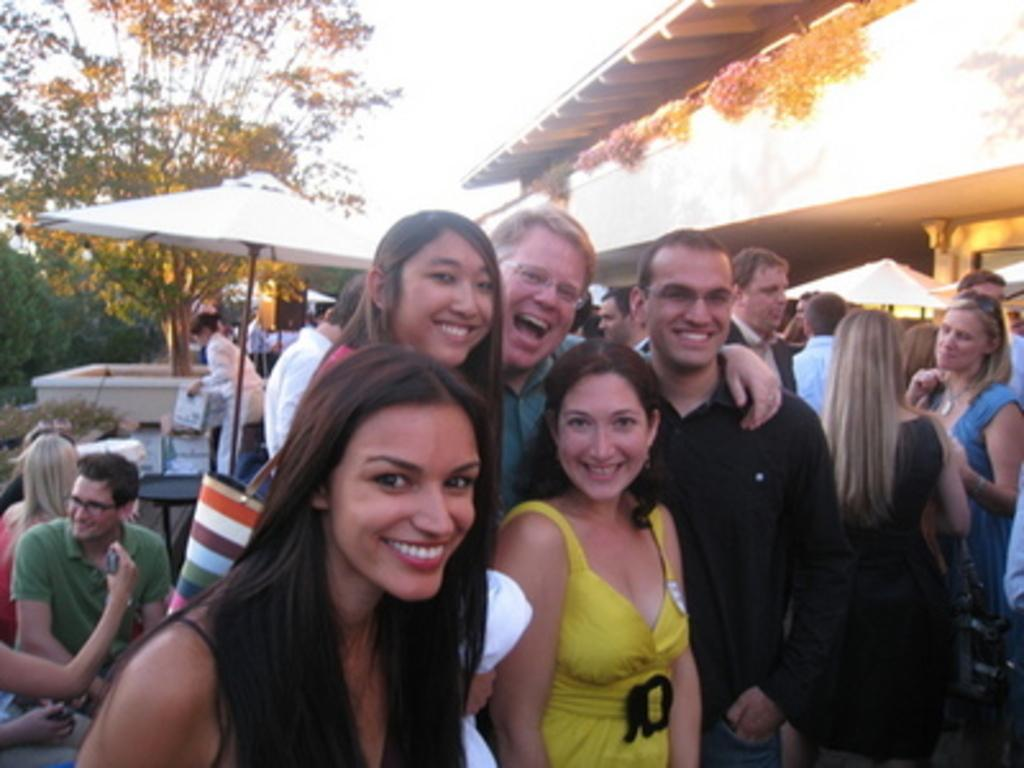How many people are in the image? There is a group of people in the image, but the exact number is not specified. What are some of the people in the image doing? Some people are standing, and some are smiling. What objects can be seen in the image besides people? There are bags, umbrellas, a building, trees, and poles in the image. What can be seen in the background of the image? The sky is visible in the background of the image. What type of advertisement can be seen on the part of the building in the image? There is no advertisement visible on any part of the building in the image. Can you see a snake slithering through the trees in the image? There is no snake present in the image. 